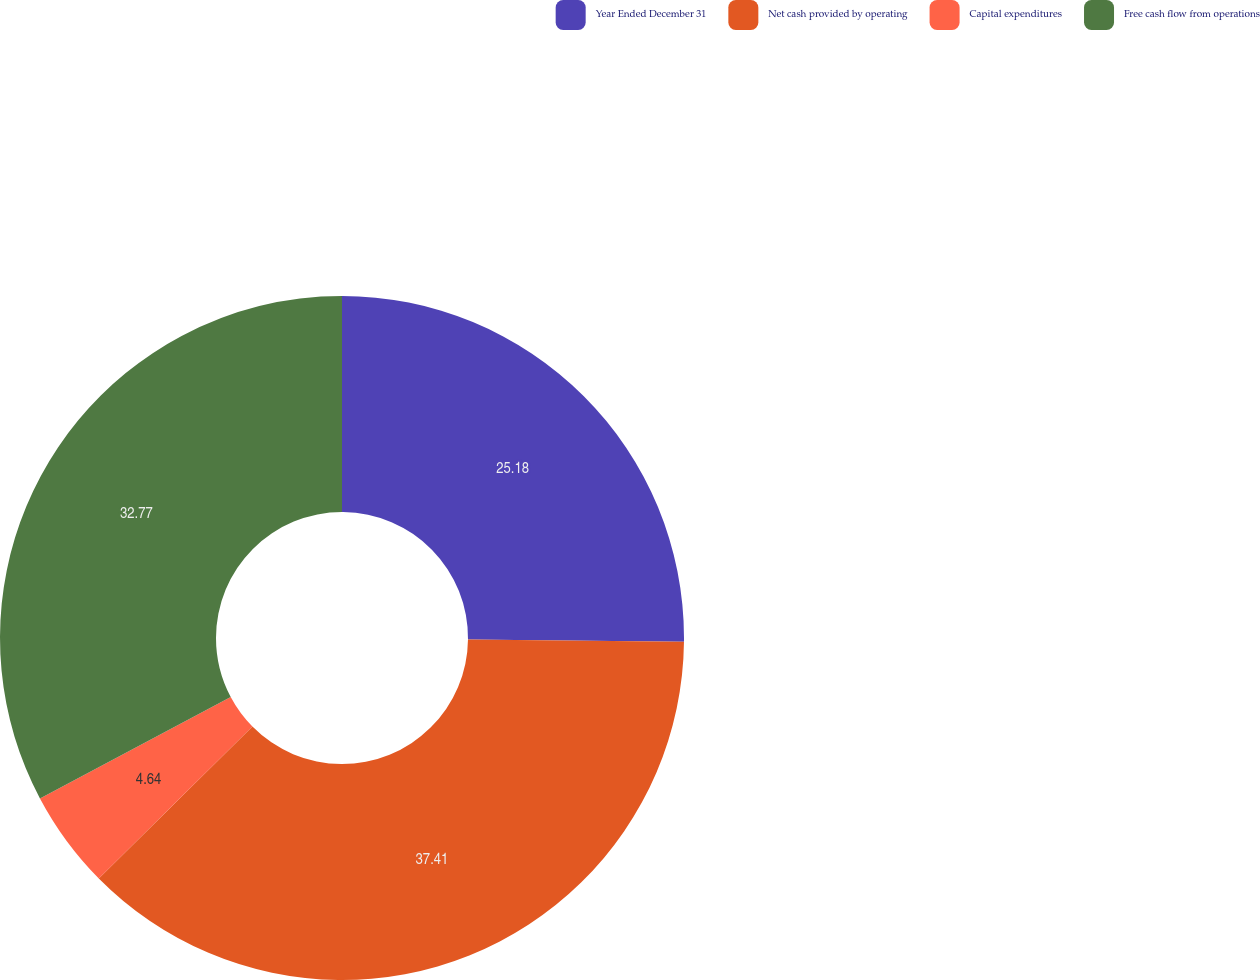<chart> <loc_0><loc_0><loc_500><loc_500><pie_chart><fcel>Year Ended December 31<fcel>Net cash provided by operating<fcel>Capital expenditures<fcel>Free cash flow from operations<nl><fcel>25.18%<fcel>37.41%<fcel>4.64%<fcel>32.77%<nl></chart> 